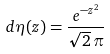<formula> <loc_0><loc_0><loc_500><loc_500>d \eta ( z ) = \frac { e ^ { - z ^ { 2 } } } { \sqrt { 2 } \, \pi }</formula> 